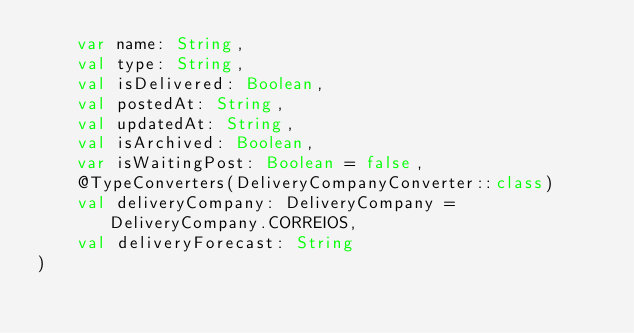Convert code to text. <code><loc_0><loc_0><loc_500><loc_500><_Kotlin_>    var name: String,
    val type: String,
    val isDelivered: Boolean,
    val postedAt: String,
    val updatedAt: String,
    val isArchived: Boolean,
    var isWaitingPost: Boolean = false,
    @TypeConverters(DeliveryCompanyConverter::class)
    val deliveryCompany: DeliveryCompany = DeliveryCompany.CORREIOS,
    val deliveryForecast: String
)
</code> 